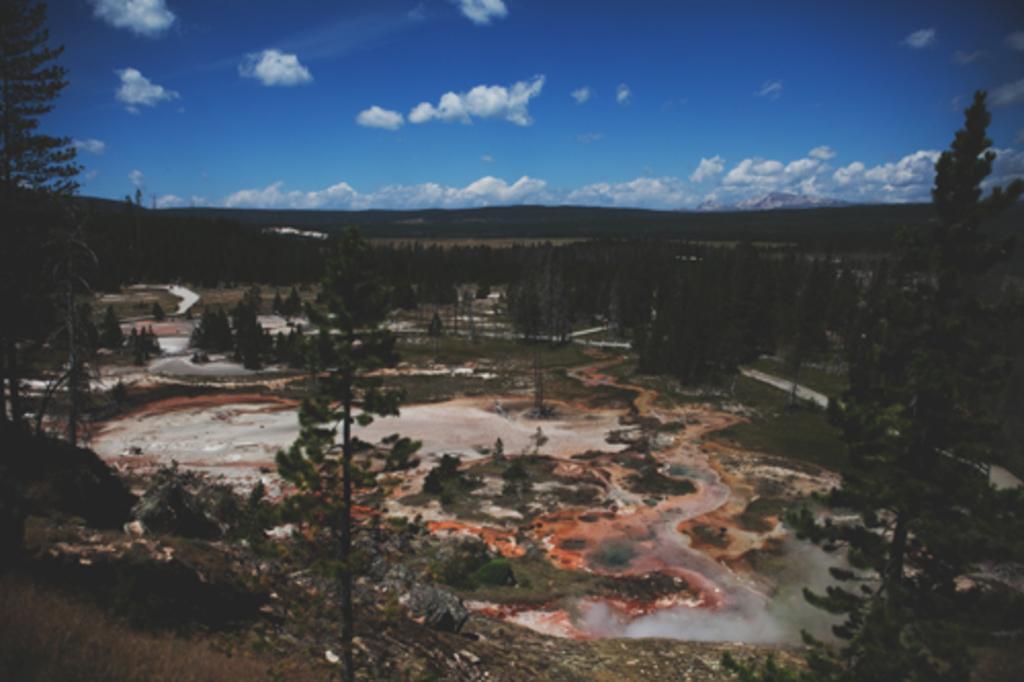Describe this image in one or two sentences. In the image I can see the view of a place where we have some trees, plants and also I can see the cloudy sky. 